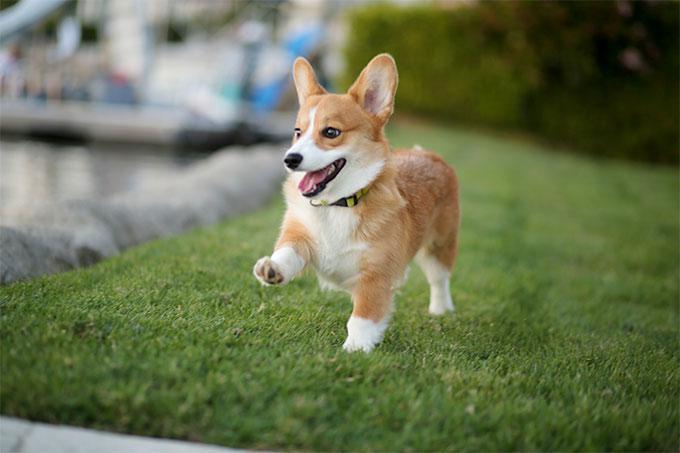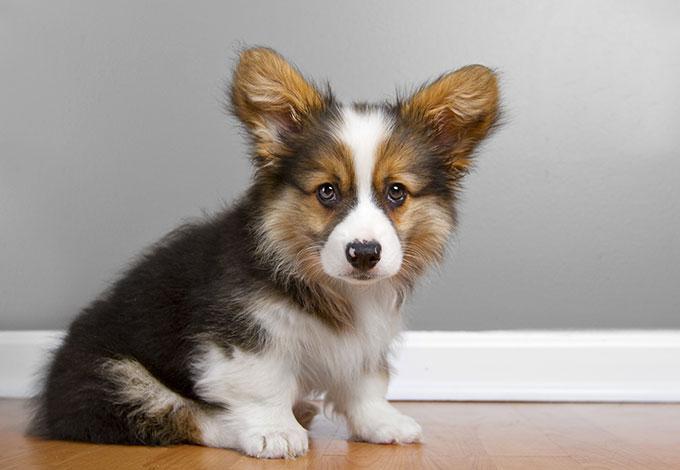The first image is the image on the left, the second image is the image on the right. Analyze the images presented: Is the assertion "the dog in the image on the left is in side profile" valid? Answer yes or no. No. The first image is the image on the left, the second image is the image on the right. Considering the images on both sides, is "A dog is walking on grass with one paw up." valid? Answer yes or no. Yes. 